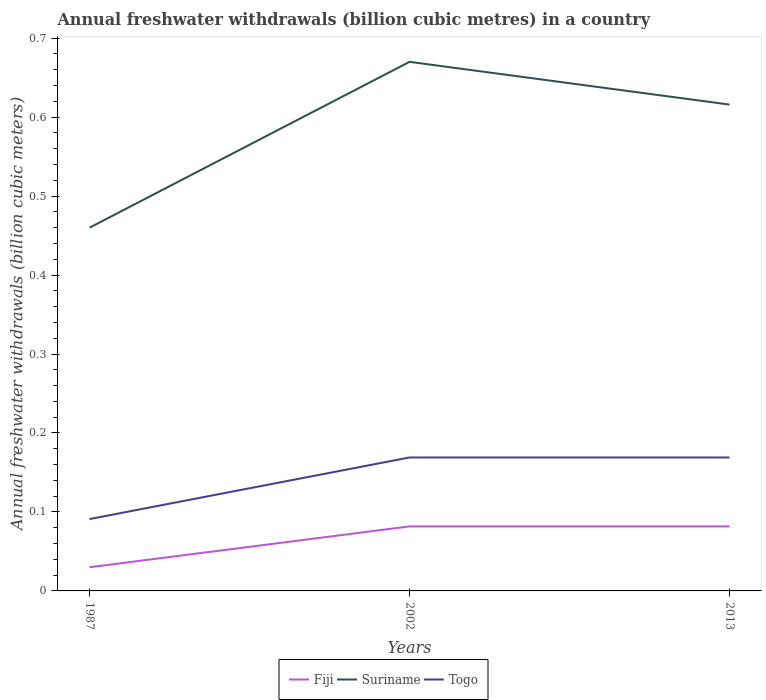Across all years, what is the maximum annual freshwater withdrawals in Togo?
Keep it short and to the point. 0.09. In which year was the annual freshwater withdrawals in Togo maximum?
Your response must be concise. 1987. What is the total annual freshwater withdrawals in Togo in the graph?
Offer a terse response. -0.08. What is the difference between the highest and the second highest annual freshwater withdrawals in Togo?
Offer a terse response. 0.08. Is the annual freshwater withdrawals in Fiji strictly greater than the annual freshwater withdrawals in Suriname over the years?
Offer a very short reply. Yes. What is the difference between two consecutive major ticks on the Y-axis?
Your answer should be compact. 0.1. Does the graph contain grids?
Your answer should be very brief. No. How are the legend labels stacked?
Offer a very short reply. Horizontal. What is the title of the graph?
Provide a succinct answer. Annual freshwater withdrawals (billion cubic metres) in a country. What is the label or title of the Y-axis?
Your answer should be very brief. Annual freshwater withdrawals (billion cubic meters). What is the Annual freshwater withdrawals (billion cubic meters) of Fiji in 1987?
Ensure brevity in your answer.  0.03. What is the Annual freshwater withdrawals (billion cubic meters) in Suriname in 1987?
Offer a terse response. 0.46. What is the Annual freshwater withdrawals (billion cubic meters) in Togo in 1987?
Make the answer very short. 0.09. What is the Annual freshwater withdrawals (billion cubic meters) in Fiji in 2002?
Your response must be concise. 0.08. What is the Annual freshwater withdrawals (billion cubic meters) in Suriname in 2002?
Your answer should be very brief. 0.67. What is the Annual freshwater withdrawals (billion cubic meters) of Togo in 2002?
Keep it short and to the point. 0.17. What is the Annual freshwater withdrawals (billion cubic meters) of Fiji in 2013?
Offer a terse response. 0.08. What is the Annual freshwater withdrawals (billion cubic meters) in Suriname in 2013?
Keep it short and to the point. 0.62. What is the Annual freshwater withdrawals (billion cubic meters) of Togo in 2013?
Your response must be concise. 0.17. Across all years, what is the maximum Annual freshwater withdrawals (billion cubic meters) of Fiji?
Make the answer very short. 0.08. Across all years, what is the maximum Annual freshwater withdrawals (billion cubic meters) in Suriname?
Your answer should be compact. 0.67. Across all years, what is the maximum Annual freshwater withdrawals (billion cubic meters) in Togo?
Provide a succinct answer. 0.17. Across all years, what is the minimum Annual freshwater withdrawals (billion cubic meters) in Suriname?
Keep it short and to the point. 0.46. Across all years, what is the minimum Annual freshwater withdrawals (billion cubic meters) in Togo?
Keep it short and to the point. 0.09. What is the total Annual freshwater withdrawals (billion cubic meters) in Fiji in the graph?
Offer a terse response. 0.19. What is the total Annual freshwater withdrawals (billion cubic meters) in Suriname in the graph?
Offer a terse response. 1.75. What is the total Annual freshwater withdrawals (billion cubic meters) in Togo in the graph?
Ensure brevity in your answer.  0.43. What is the difference between the Annual freshwater withdrawals (billion cubic meters) of Fiji in 1987 and that in 2002?
Offer a very short reply. -0.05. What is the difference between the Annual freshwater withdrawals (billion cubic meters) in Suriname in 1987 and that in 2002?
Your answer should be compact. -0.21. What is the difference between the Annual freshwater withdrawals (billion cubic meters) of Togo in 1987 and that in 2002?
Provide a succinct answer. -0.08. What is the difference between the Annual freshwater withdrawals (billion cubic meters) in Fiji in 1987 and that in 2013?
Your response must be concise. -0.05. What is the difference between the Annual freshwater withdrawals (billion cubic meters) of Suriname in 1987 and that in 2013?
Offer a terse response. -0.16. What is the difference between the Annual freshwater withdrawals (billion cubic meters) of Togo in 1987 and that in 2013?
Your answer should be very brief. -0.08. What is the difference between the Annual freshwater withdrawals (billion cubic meters) in Fiji in 2002 and that in 2013?
Make the answer very short. 0. What is the difference between the Annual freshwater withdrawals (billion cubic meters) of Suriname in 2002 and that in 2013?
Your answer should be compact. 0.05. What is the difference between the Annual freshwater withdrawals (billion cubic meters) of Togo in 2002 and that in 2013?
Give a very brief answer. 0. What is the difference between the Annual freshwater withdrawals (billion cubic meters) in Fiji in 1987 and the Annual freshwater withdrawals (billion cubic meters) in Suriname in 2002?
Provide a short and direct response. -0.64. What is the difference between the Annual freshwater withdrawals (billion cubic meters) in Fiji in 1987 and the Annual freshwater withdrawals (billion cubic meters) in Togo in 2002?
Ensure brevity in your answer.  -0.14. What is the difference between the Annual freshwater withdrawals (billion cubic meters) in Suriname in 1987 and the Annual freshwater withdrawals (billion cubic meters) in Togo in 2002?
Keep it short and to the point. 0.29. What is the difference between the Annual freshwater withdrawals (billion cubic meters) of Fiji in 1987 and the Annual freshwater withdrawals (billion cubic meters) of Suriname in 2013?
Ensure brevity in your answer.  -0.59. What is the difference between the Annual freshwater withdrawals (billion cubic meters) in Fiji in 1987 and the Annual freshwater withdrawals (billion cubic meters) in Togo in 2013?
Ensure brevity in your answer.  -0.14. What is the difference between the Annual freshwater withdrawals (billion cubic meters) in Suriname in 1987 and the Annual freshwater withdrawals (billion cubic meters) in Togo in 2013?
Offer a very short reply. 0.29. What is the difference between the Annual freshwater withdrawals (billion cubic meters) in Fiji in 2002 and the Annual freshwater withdrawals (billion cubic meters) in Suriname in 2013?
Your answer should be compact. -0.53. What is the difference between the Annual freshwater withdrawals (billion cubic meters) in Fiji in 2002 and the Annual freshwater withdrawals (billion cubic meters) in Togo in 2013?
Ensure brevity in your answer.  -0.09. What is the difference between the Annual freshwater withdrawals (billion cubic meters) in Suriname in 2002 and the Annual freshwater withdrawals (billion cubic meters) in Togo in 2013?
Make the answer very short. 0.5. What is the average Annual freshwater withdrawals (billion cubic meters) of Fiji per year?
Give a very brief answer. 0.06. What is the average Annual freshwater withdrawals (billion cubic meters) in Suriname per year?
Give a very brief answer. 0.58. What is the average Annual freshwater withdrawals (billion cubic meters) in Togo per year?
Give a very brief answer. 0.14. In the year 1987, what is the difference between the Annual freshwater withdrawals (billion cubic meters) of Fiji and Annual freshwater withdrawals (billion cubic meters) of Suriname?
Your answer should be compact. -0.43. In the year 1987, what is the difference between the Annual freshwater withdrawals (billion cubic meters) of Fiji and Annual freshwater withdrawals (billion cubic meters) of Togo?
Keep it short and to the point. -0.06. In the year 1987, what is the difference between the Annual freshwater withdrawals (billion cubic meters) of Suriname and Annual freshwater withdrawals (billion cubic meters) of Togo?
Provide a succinct answer. 0.37. In the year 2002, what is the difference between the Annual freshwater withdrawals (billion cubic meters) in Fiji and Annual freshwater withdrawals (billion cubic meters) in Suriname?
Give a very brief answer. -0.59. In the year 2002, what is the difference between the Annual freshwater withdrawals (billion cubic meters) in Fiji and Annual freshwater withdrawals (billion cubic meters) in Togo?
Your answer should be very brief. -0.09. In the year 2002, what is the difference between the Annual freshwater withdrawals (billion cubic meters) of Suriname and Annual freshwater withdrawals (billion cubic meters) of Togo?
Your response must be concise. 0.5. In the year 2013, what is the difference between the Annual freshwater withdrawals (billion cubic meters) in Fiji and Annual freshwater withdrawals (billion cubic meters) in Suriname?
Ensure brevity in your answer.  -0.53. In the year 2013, what is the difference between the Annual freshwater withdrawals (billion cubic meters) in Fiji and Annual freshwater withdrawals (billion cubic meters) in Togo?
Offer a terse response. -0.09. In the year 2013, what is the difference between the Annual freshwater withdrawals (billion cubic meters) of Suriname and Annual freshwater withdrawals (billion cubic meters) of Togo?
Your response must be concise. 0.45. What is the ratio of the Annual freshwater withdrawals (billion cubic meters) of Fiji in 1987 to that in 2002?
Offer a terse response. 0.37. What is the ratio of the Annual freshwater withdrawals (billion cubic meters) of Suriname in 1987 to that in 2002?
Provide a short and direct response. 0.69. What is the ratio of the Annual freshwater withdrawals (billion cubic meters) in Togo in 1987 to that in 2002?
Your response must be concise. 0.54. What is the ratio of the Annual freshwater withdrawals (billion cubic meters) in Fiji in 1987 to that in 2013?
Ensure brevity in your answer.  0.37. What is the ratio of the Annual freshwater withdrawals (billion cubic meters) of Suriname in 1987 to that in 2013?
Offer a terse response. 0.75. What is the ratio of the Annual freshwater withdrawals (billion cubic meters) of Togo in 1987 to that in 2013?
Give a very brief answer. 0.54. What is the ratio of the Annual freshwater withdrawals (billion cubic meters) of Suriname in 2002 to that in 2013?
Your response must be concise. 1.09. What is the difference between the highest and the second highest Annual freshwater withdrawals (billion cubic meters) of Suriname?
Your answer should be compact. 0.05. What is the difference between the highest and the second highest Annual freshwater withdrawals (billion cubic meters) in Togo?
Provide a succinct answer. 0. What is the difference between the highest and the lowest Annual freshwater withdrawals (billion cubic meters) in Fiji?
Your answer should be very brief. 0.05. What is the difference between the highest and the lowest Annual freshwater withdrawals (billion cubic meters) in Suriname?
Your answer should be very brief. 0.21. What is the difference between the highest and the lowest Annual freshwater withdrawals (billion cubic meters) of Togo?
Ensure brevity in your answer.  0.08. 